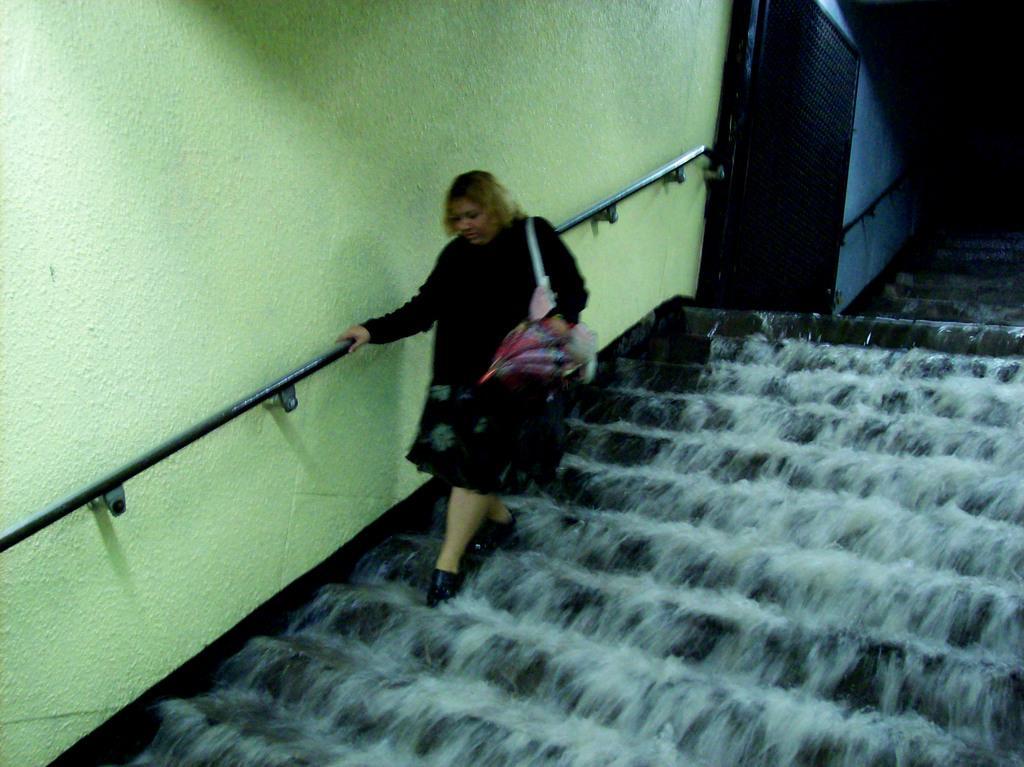Could you give a brief overview of what you see in this image? In this image I can see a wall, metal rods, door, water and a woman is climbing on the steps. This image is taken may be during a day. 